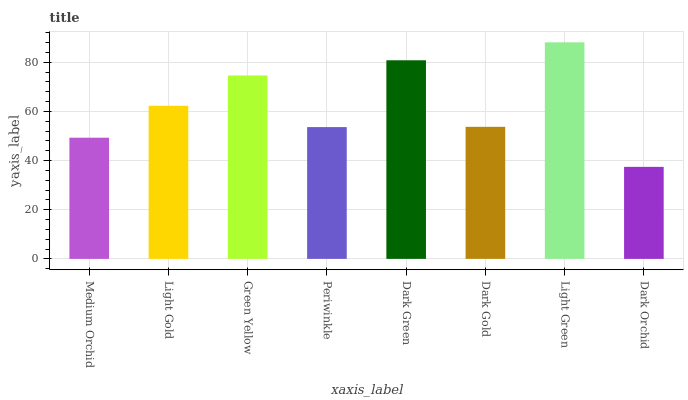Is Dark Orchid the minimum?
Answer yes or no. Yes. Is Light Green the maximum?
Answer yes or no. Yes. Is Light Gold the minimum?
Answer yes or no. No. Is Light Gold the maximum?
Answer yes or no. No. Is Light Gold greater than Medium Orchid?
Answer yes or no. Yes. Is Medium Orchid less than Light Gold?
Answer yes or no. Yes. Is Medium Orchid greater than Light Gold?
Answer yes or no. No. Is Light Gold less than Medium Orchid?
Answer yes or no. No. Is Light Gold the high median?
Answer yes or no. Yes. Is Dark Gold the low median?
Answer yes or no. Yes. Is Dark Gold the high median?
Answer yes or no. No. Is Periwinkle the low median?
Answer yes or no. No. 